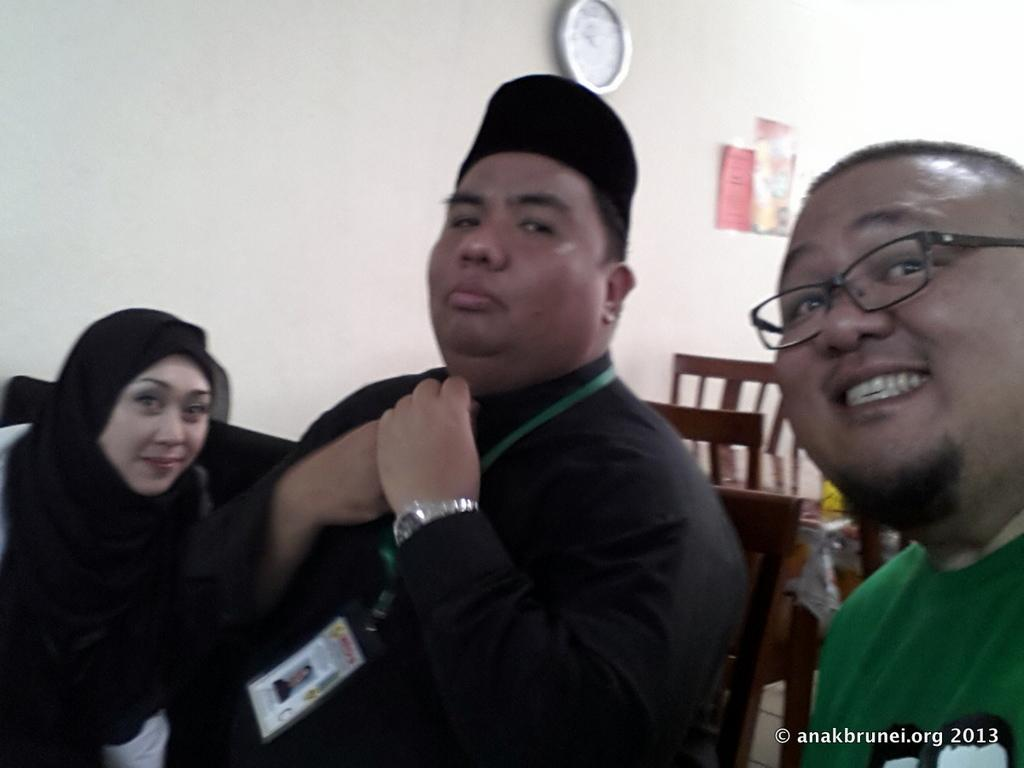What are the people in the image doing? There are persons sitting on chairs in the image. What can be seen on the wall in the background? Papers are pasted on the wall in the background. Can you describe the furniture in the background? There are chairs and a table visible in the background. What time-keeping device is present in the background? A wall clock is present in the background. What type of grip does the rat have on the gun in the image? There is no rat or gun present in the image. 